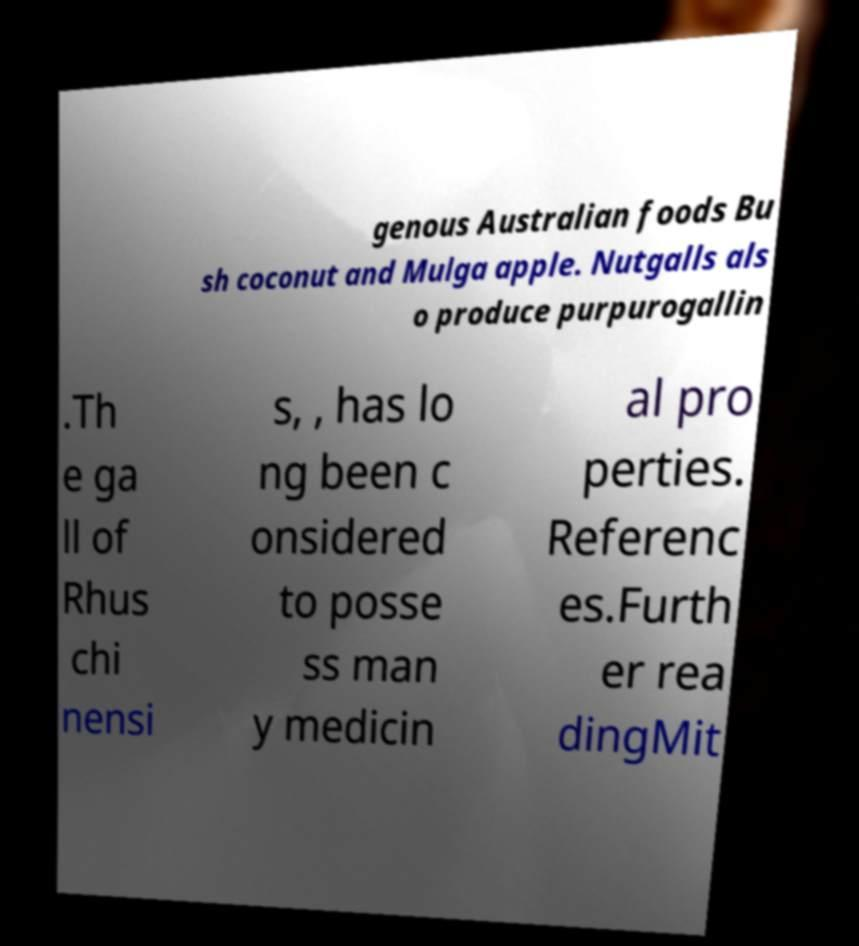What messages or text are displayed in this image? I need them in a readable, typed format. genous Australian foods Bu sh coconut and Mulga apple. Nutgalls als o produce purpurogallin .Th e ga ll of Rhus chi nensi s, , has lo ng been c onsidered to posse ss man y medicin al pro perties. Referenc es.Furth er rea dingMit 